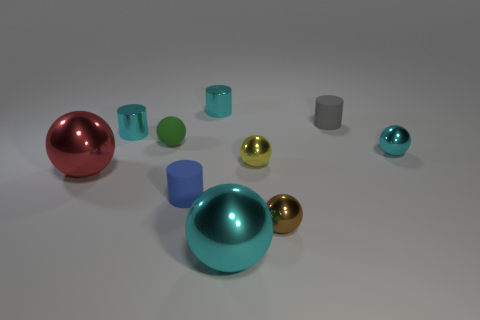Are there fewer large objects on the left side of the red metal sphere than tiny matte things that are right of the tiny blue cylinder?
Your answer should be compact. Yes. What color is the other small matte thing that is the same shape as the gray rubber object?
Keep it short and to the point. Blue. How big is the green rubber object?
Your answer should be compact. Small. What number of cyan shiny cylinders have the same size as the matte sphere?
Provide a succinct answer. 2. Does the cyan cylinder that is on the right side of the blue object have the same material as the green ball to the left of the gray cylinder?
Offer a very short reply. No. Is the number of blue rubber objects greater than the number of tiny green metallic cubes?
Your response must be concise. Yes. Is there anything else that is the same color as the matte ball?
Your answer should be very brief. No. Are the tiny gray cylinder and the large red ball made of the same material?
Your answer should be compact. No. Are there fewer big cyan things than shiny objects?
Keep it short and to the point. Yes. Does the tiny blue matte object have the same shape as the tiny yellow object?
Offer a very short reply. No. 